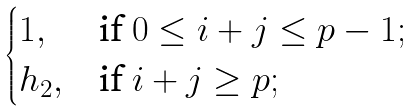<formula> <loc_0><loc_0><loc_500><loc_500>\begin{cases} 1 , & \text {if } 0 \leq i + j \leq p - 1 ; \\ h _ { 2 } , & \text {if } i + j \geq p ; \end{cases}</formula> 